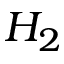<formula> <loc_0><loc_0><loc_500><loc_500>H _ { 2 }</formula> 